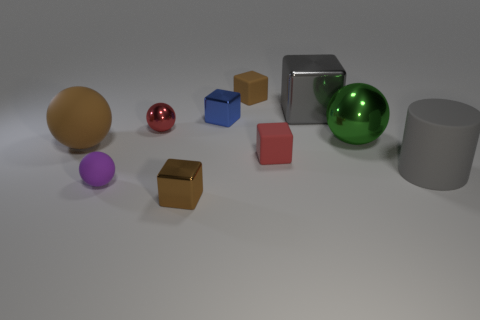What materials appear to be represented by the objects in the image? The objects in the image resemble materials such as matte plastic for the colored shapes, reflective metal for the silver cylinder and box, and possibly glass for the shiny green sphere. 